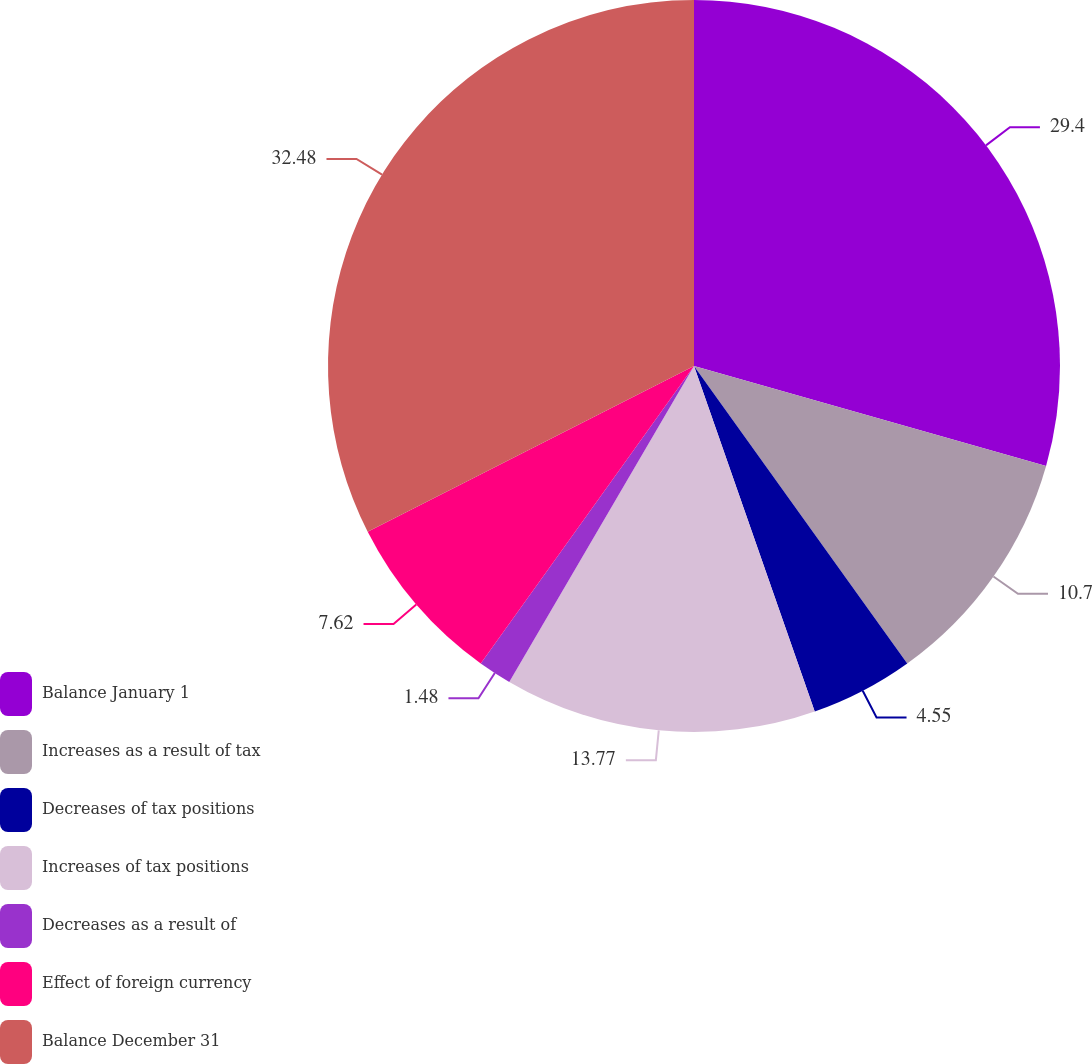<chart> <loc_0><loc_0><loc_500><loc_500><pie_chart><fcel>Balance January 1<fcel>Increases as a result of tax<fcel>Decreases of tax positions<fcel>Increases of tax positions<fcel>Decreases as a result of<fcel>Effect of foreign currency<fcel>Balance December 31<nl><fcel>29.4%<fcel>10.7%<fcel>4.55%<fcel>13.77%<fcel>1.48%<fcel>7.62%<fcel>32.48%<nl></chart> 